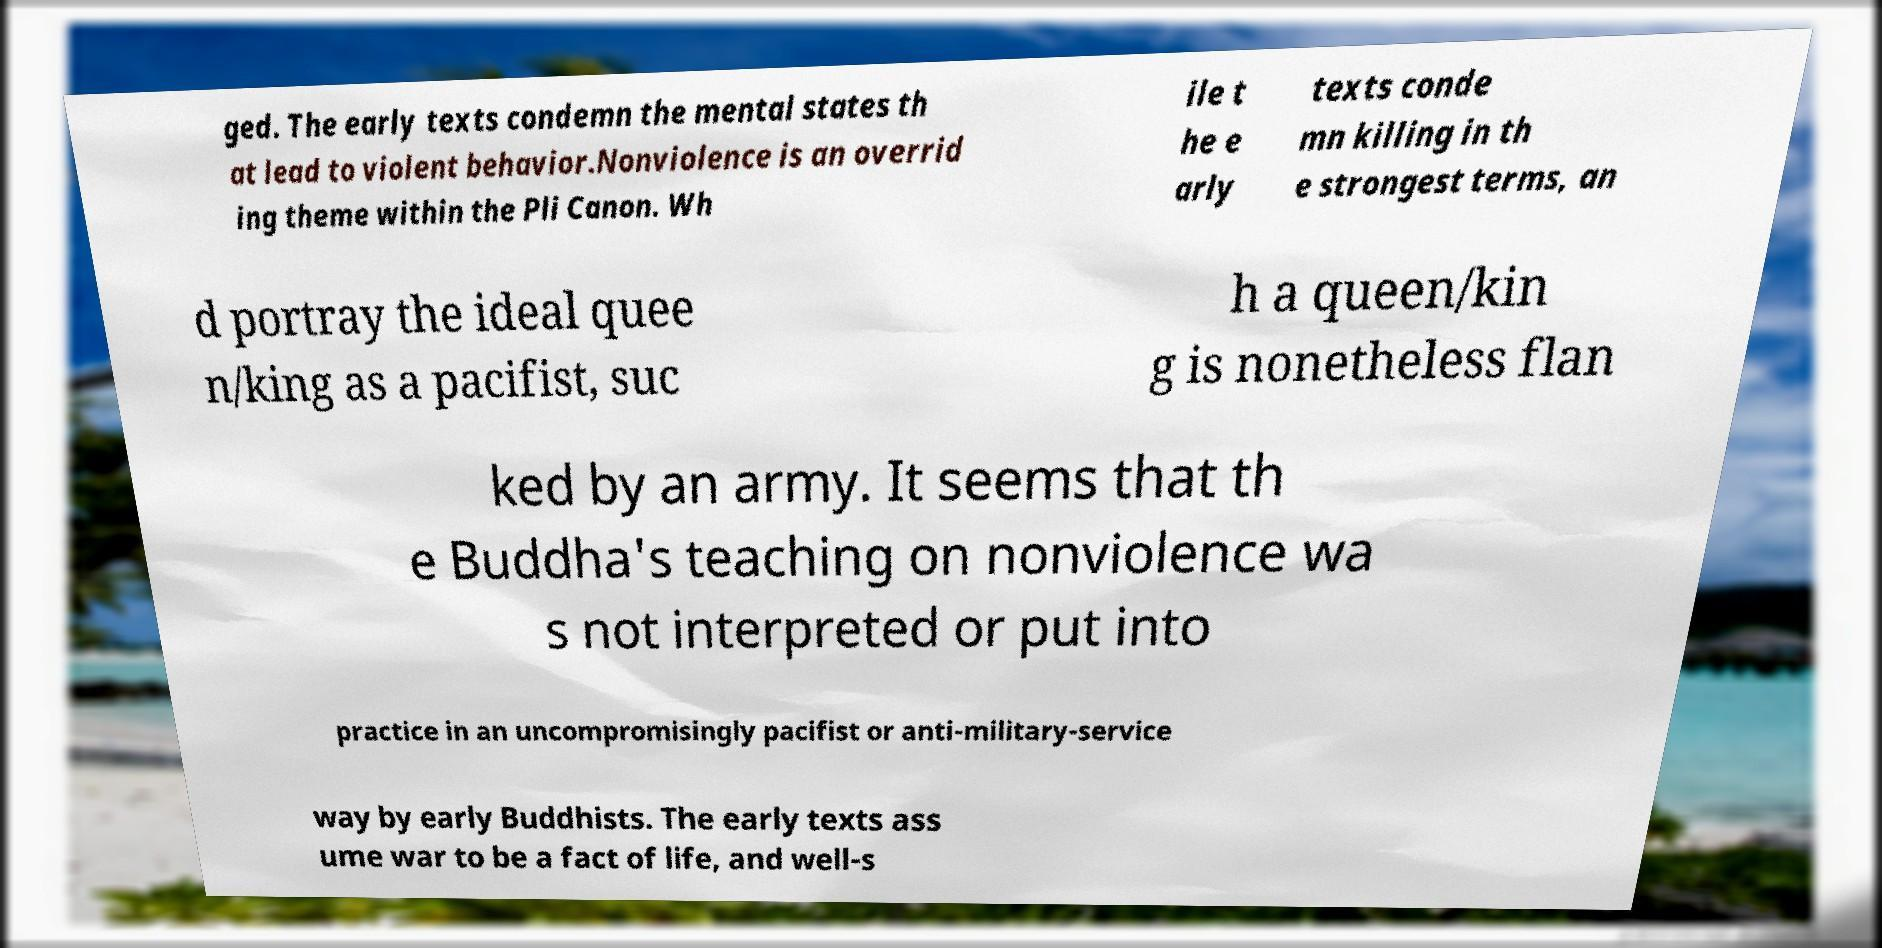Can you accurately transcribe the text from the provided image for me? ged. The early texts condemn the mental states th at lead to violent behavior.Nonviolence is an overrid ing theme within the Pli Canon. Wh ile t he e arly texts conde mn killing in th e strongest terms, an d portray the ideal quee n/king as a pacifist, suc h a queen/kin g is nonetheless flan ked by an army. It seems that th e Buddha's teaching on nonviolence wa s not interpreted or put into practice in an uncompromisingly pacifist or anti-military-service way by early Buddhists. The early texts ass ume war to be a fact of life, and well-s 